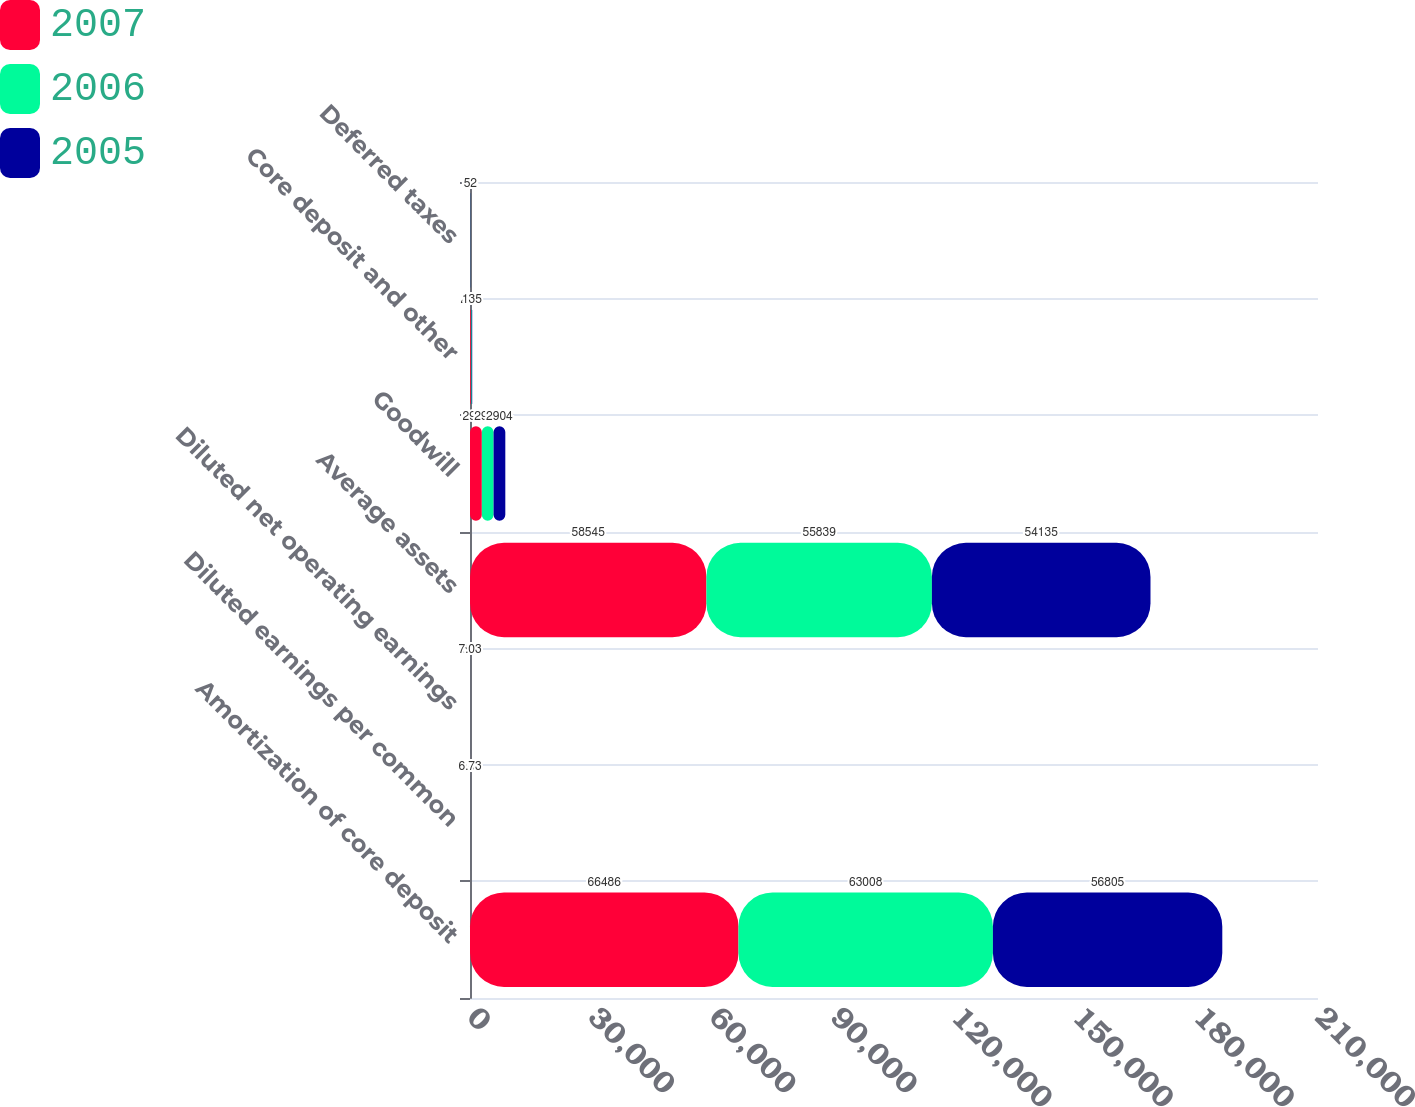Convert chart to OTSL. <chart><loc_0><loc_0><loc_500><loc_500><stacked_bar_chart><ecel><fcel>Amortization of core deposit<fcel>Diluted earnings per common<fcel>Diluted net operating earnings<fcel>Average assets<fcel>Goodwill<fcel>Core deposit and other<fcel>Deferred taxes<nl><fcel>2007<fcel>66486<fcel>5.95<fcel>6.4<fcel>58545<fcel>2933<fcel>221<fcel>24<nl><fcel>2006<fcel>63008<fcel>7.37<fcel>7.73<fcel>55839<fcel>2908<fcel>191<fcel>38<nl><fcel>2005<fcel>56805<fcel>6.73<fcel>7.03<fcel>54135<fcel>2904<fcel>135<fcel>52<nl></chart> 